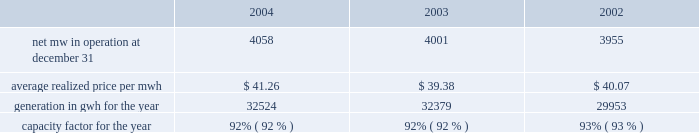Entergy corporation and subsidiaries management's financial discussion and analysis other income ( deductions ) changed from $ 47.6 million in 2002 to ( $ 36.0 million ) in 2003 primarily due to a decrease in "miscellaneous - net" as a result of a $ 107.7 million accrual in the second quarter of 2003 for the loss that would be associated with a final , non-appealable decision disallowing abeyed river bend plant costs .
See note 2 to the consolidated financial statements for more details regarding the river bend abeyed plant costs .
The decrease was partially offset by an increase in interest and dividend income as a result of the implementation of sfas 143 .
Interest on long-term debt decreased from $ 462.0 million in 2002 to $ 433.5 million in 2003 primarily due to the redemption and refinancing of long-term debt .
Non-utility nuclear following are key performance measures for non-utility nuclear: .
2004 compared to 2003 the decrease in earnings for non-utility nuclear from $ 300.8 million to $ 245.0 million was primarily due to the $ 154.5 million net-of-tax cumulative effect of a change in accounting principle that increased earnings in the first quarter of 2003 upon implementation of sfas 143 .
See "critical accounting estimates - sfas 143" below for discussion of the implementation of sfas 143 .
Earnings before the cumulative effect of accounting change increased by $ 98.7 million primarily due to the following : 2022 lower operation and maintenance expenses , which decreased from $ 681.8 million in 2003 to $ 595.7 million in 2004 , primarily resulting from charges recorded in 2003 in connection with the voluntary severance program ; 2022 higher revenues , which increased from $ 1.275 billion in 2003 to $ 1.342 billion in 2004 , primarily resulting from higher contract pricing .
The addition of a support services contract for the cooper nuclear station and increased generation in 2004 due to power uprates completed in 2003 and fewer planned and unplanned outages in 2004 also contributed to the higher revenues ; and 2022 miscellaneous income resulting from a reduction in the decommissioning liability for a plant , as discussed in note 8 to the consolidated financial statements .
Partially offsetting this increase were the following : 2022 higher income taxes , which increased from $ 88.6 million in 2003 to $ 142.6 million in 2004 ; and 2022 higher depreciation expense , which increased from $ 34.3 million in 2003 to $ 48.9 million in 2004 , due to additions to plant in service .
2003 compared to 2002 the increase in earnings for non-utility nuclear from $ 200.5 million to $ 300.8 million was primarily due to the $ 154.5 million net-of-tax cumulative effect of a change in accounting principle recognized in the first quarter of 2003 upon implementation of sfas 143 .
See "critical accounting estimates - sfas 143" below for discussion of the implementation of sfas 143 .
Income before the cumulative effect of accounting change decreased by $ 54.2 million .
The decrease was primarily due to $ 83.0 million ( $ 50.6 million net-of-tax ) of charges recorded in connection with the voluntary severance program .
Except for the effect of the voluntary severance program , operation and maintenance expenses in 2003 per mwh of generation were in line with 2002 operation and maintenance expenses. .
What is the growth rate in generated gwh per year in 2004 compare to 2003? 
Computations: ((32524 - 32379) / 32379)
Answer: 0.00448. Entergy corporation and subsidiaries management's financial discussion and analysis other income ( deductions ) changed from $ 47.6 million in 2002 to ( $ 36.0 million ) in 2003 primarily due to a decrease in "miscellaneous - net" as a result of a $ 107.7 million accrual in the second quarter of 2003 for the loss that would be associated with a final , non-appealable decision disallowing abeyed river bend plant costs .
See note 2 to the consolidated financial statements for more details regarding the river bend abeyed plant costs .
The decrease was partially offset by an increase in interest and dividend income as a result of the implementation of sfas 143 .
Interest on long-term debt decreased from $ 462.0 million in 2002 to $ 433.5 million in 2003 primarily due to the redemption and refinancing of long-term debt .
Non-utility nuclear following are key performance measures for non-utility nuclear: .
2004 compared to 2003 the decrease in earnings for non-utility nuclear from $ 300.8 million to $ 245.0 million was primarily due to the $ 154.5 million net-of-tax cumulative effect of a change in accounting principle that increased earnings in the first quarter of 2003 upon implementation of sfas 143 .
See "critical accounting estimates - sfas 143" below for discussion of the implementation of sfas 143 .
Earnings before the cumulative effect of accounting change increased by $ 98.7 million primarily due to the following : 2022 lower operation and maintenance expenses , which decreased from $ 681.8 million in 2003 to $ 595.7 million in 2004 , primarily resulting from charges recorded in 2003 in connection with the voluntary severance program ; 2022 higher revenues , which increased from $ 1.275 billion in 2003 to $ 1.342 billion in 2004 , primarily resulting from higher contract pricing .
The addition of a support services contract for the cooper nuclear station and increased generation in 2004 due to power uprates completed in 2003 and fewer planned and unplanned outages in 2004 also contributed to the higher revenues ; and 2022 miscellaneous income resulting from a reduction in the decommissioning liability for a plant , as discussed in note 8 to the consolidated financial statements .
Partially offsetting this increase were the following : 2022 higher income taxes , which increased from $ 88.6 million in 2003 to $ 142.6 million in 2004 ; and 2022 higher depreciation expense , which increased from $ 34.3 million in 2003 to $ 48.9 million in 2004 , due to additions to plant in service .
2003 compared to 2002 the increase in earnings for non-utility nuclear from $ 200.5 million to $ 300.8 million was primarily due to the $ 154.5 million net-of-tax cumulative effect of a change in accounting principle recognized in the first quarter of 2003 upon implementation of sfas 143 .
See "critical accounting estimates - sfas 143" below for discussion of the implementation of sfas 143 .
Income before the cumulative effect of accounting change decreased by $ 54.2 million .
The decrease was primarily due to $ 83.0 million ( $ 50.6 million net-of-tax ) of charges recorded in connection with the voluntary severance program .
Except for the effect of the voluntary severance program , operation and maintenance expenses in 2003 per mwh of generation were in line with 2002 operation and maintenance expenses. .
What is the growth rate in earnings for non-utility nuclear in 2004 compare to 2003? 
Computations: ((245.0 - 300.8) / 300.8)
Answer: -0.18551. 